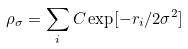<formula> <loc_0><loc_0><loc_500><loc_500>\rho _ { \sigma } = \sum _ { i } C \exp [ - r _ { i } / 2 \sigma ^ { 2 } ]</formula> 